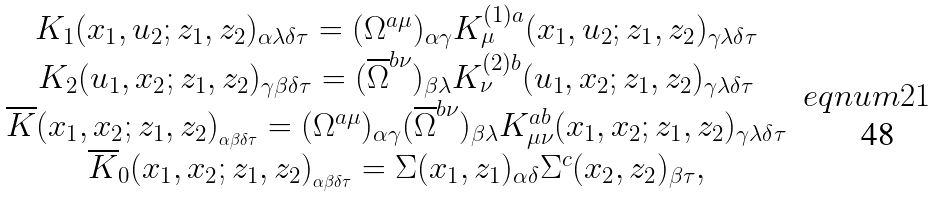<formula> <loc_0><loc_0><loc_500><loc_500>\begin{array} { c } K _ { 1 } ( x _ { 1 } , u _ { 2 } ; z _ { 1 } , z _ { 2 } ) _ { \alpha \lambda \delta \tau } = ( \Omega ^ { a \mu } ) _ { \alpha \gamma } K _ { \mu } ^ { ( 1 ) a } ( x _ { 1 } , u _ { 2 } ; z _ { 1 } , z _ { 2 } ) _ { \gamma \lambda \delta \tau } \\ K _ { 2 } ( u _ { 1 } , x _ { 2 } ; z _ { 1 } , z _ { 2 } ) _ { \gamma \beta \delta \tau } = ( \overline { \Omega } ^ { b \nu } ) _ { \beta \lambda } K _ { \nu } ^ { ( 2 ) b } ( u _ { 1 } , x _ { 2 } ; z _ { 1 } , z _ { 2 } ) _ { \gamma \lambda \delta \tau } \\ \overline { K } ( x _ { 1 } , x _ { 2 } ; z _ { 1 } , z _ { 2 } ) _ { _ { \alpha \beta \delta \tau } } = ( \Omega ^ { a \mu } ) _ { \alpha \gamma } ( \overline { \Omega } ^ { b \nu } ) _ { \beta \lambda } K _ { \mu \nu } ^ { a b } ( x _ { 1 } , x _ { 2 } ; z _ { 1 } , z _ { 2 } ) _ { \gamma \lambda \delta \tau } \\ \overline { K } _ { 0 } ( x _ { 1 } , x _ { 2 } ; z _ { 1 } , z _ { 2 } ) _ { _ { \alpha \beta \delta \tau } } = \Sigma ( x _ { 1 } , z _ { 1 } ) _ { \alpha \delta } \Sigma ^ { c } ( x _ { 2 } , z _ { 2 } ) _ { \beta \tau } , \end{array} \ e q n u m { 2 1 }</formula> 